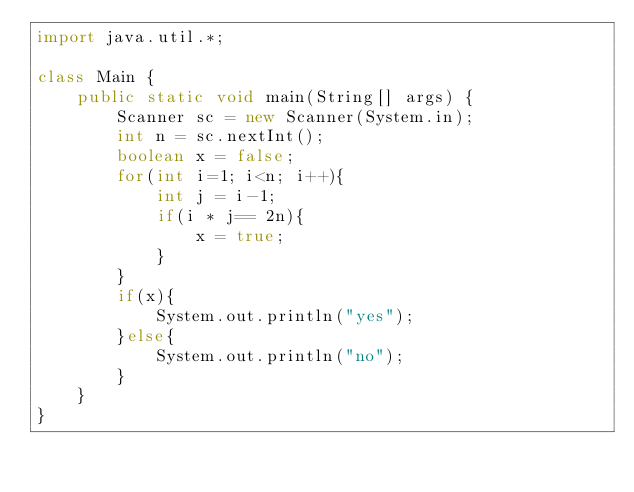<code> <loc_0><loc_0><loc_500><loc_500><_Java_>import java.util.*;

class Main {
    public static void main(String[] args) {
        Scanner sc = new Scanner(System.in);
        int n = sc.nextInt();
        boolean x = false;
        for(int i=1; i<n; i++){
            int j = i-1;
            if(i * j== 2n){
                x = true;
            }
        }
        if(x){
            System.out.println("yes");
        }else{
            System.out.println("no");
        }
    }
}</code> 